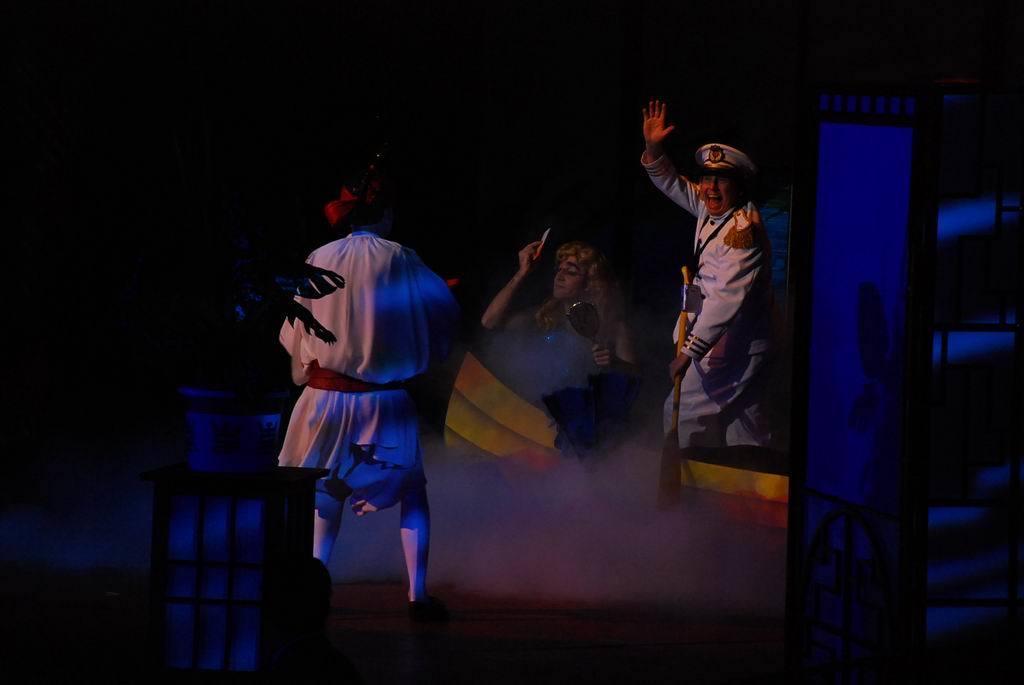In one or two sentences, can you explain what this image depicts? In this picture I can see a person holding the wooden object on the right side. I can see a person holding mirror. I can see a person on the left side. 